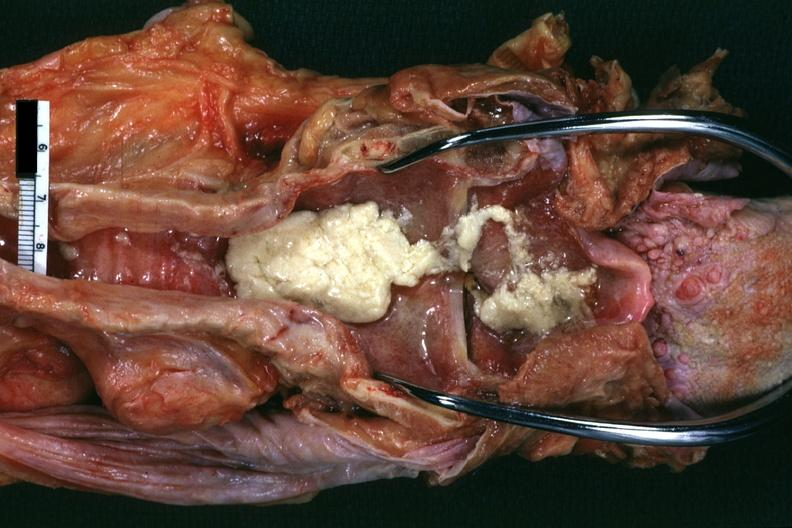does this image show aspirated mucus excellent?
Answer the question using a single word or phrase. Yes 